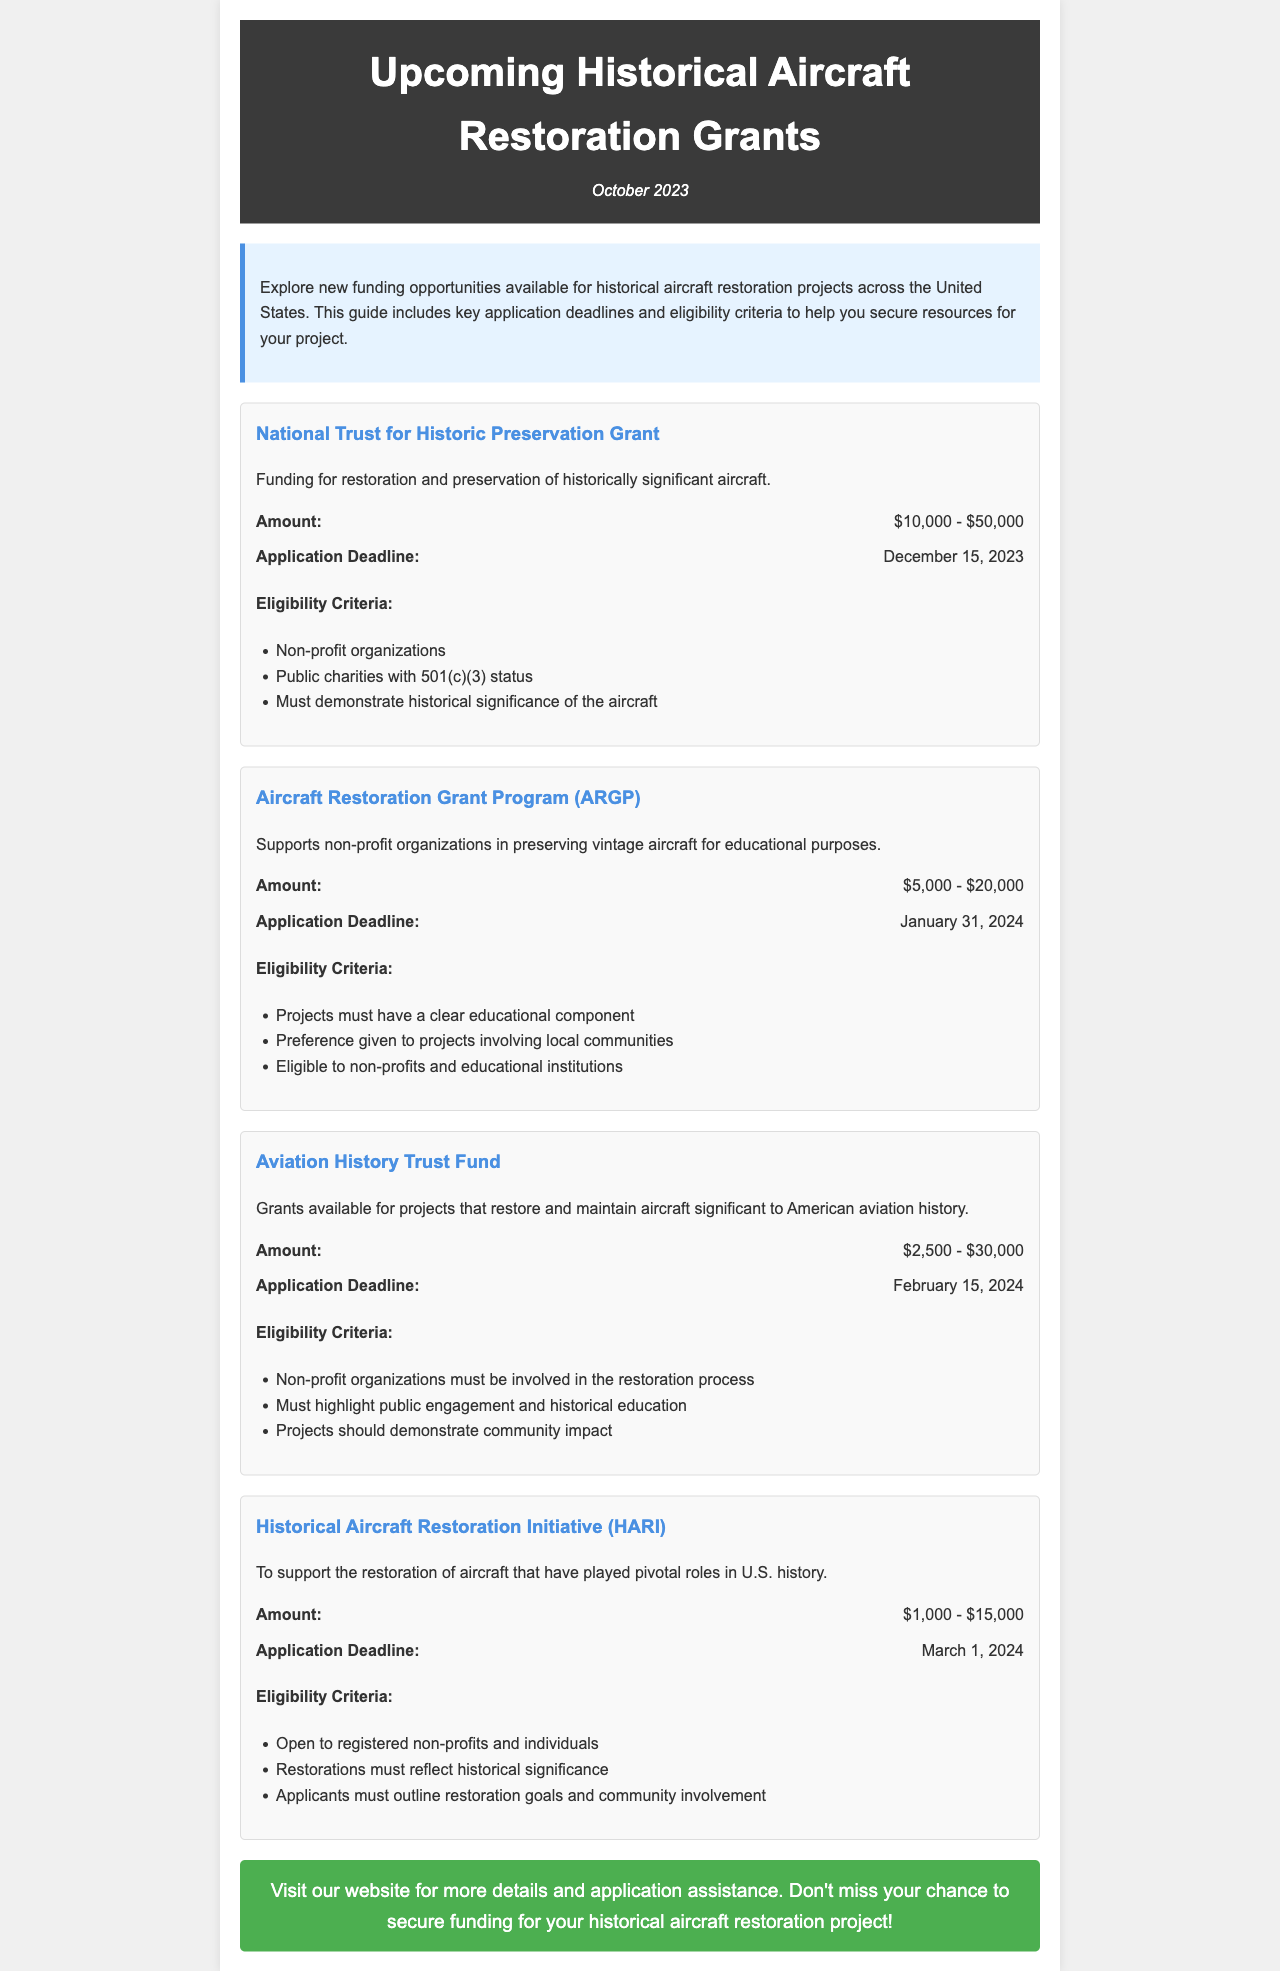What is the funding amount for the National Trust for Historic Preservation Grant? The funding amount for this grant ranges from $10,000 to $50,000.
Answer: $10,000 - $50,000 When is the application deadline for the Aviation History Trust Fund? The application deadline for this fund is February 15, 2024.
Answer: February 15, 2024 Who is eligible to apply for the Historical Aircraft Restoration Initiative (HARI)? Eligibility is open to registered non-profits and individuals.
Answer: Registered non-profits and individuals What type of projects does the Aircraft Restoration Grant Program (ARGP) support? This program supports projects that have a clear educational component.
Answer: Educational component How much funding is available through the Historical Aircraft Restoration Initiative (HARI)? The funding amount for HARI ranges from $1,000 to $15,000.
Answer: $1,000 - $15,000 Which grant has the earliest application deadline? The National Trust for Historic Preservation Grant has the earliest deadline on December 15, 2023.
Answer: December 15, 2023 What is a requirement for the Aviation History Trust Fund eligibility? Projects must highlight public engagement and historical education.
Answer: Public engagement and historical education What is the main focus of the grants mentioned in the document? The main focus is on restoring and preserving historical aircraft.
Answer: Restoring and preserving historical aircraft 